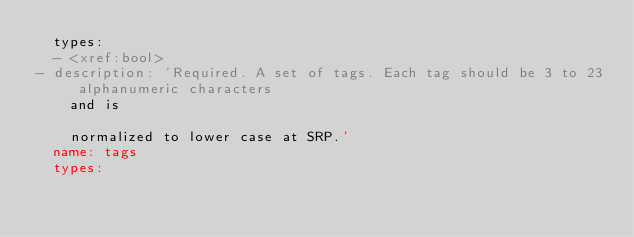Convert code to text. <code><loc_0><loc_0><loc_500><loc_500><_YAML_>  types:
  - <xref:bool>
- description: 'Required. A set of tags. Each tag should be 3 to 23 alphanumeric characters
    and is

    normalized to lower case at SRP.'
  name: tags
  types:</code> 